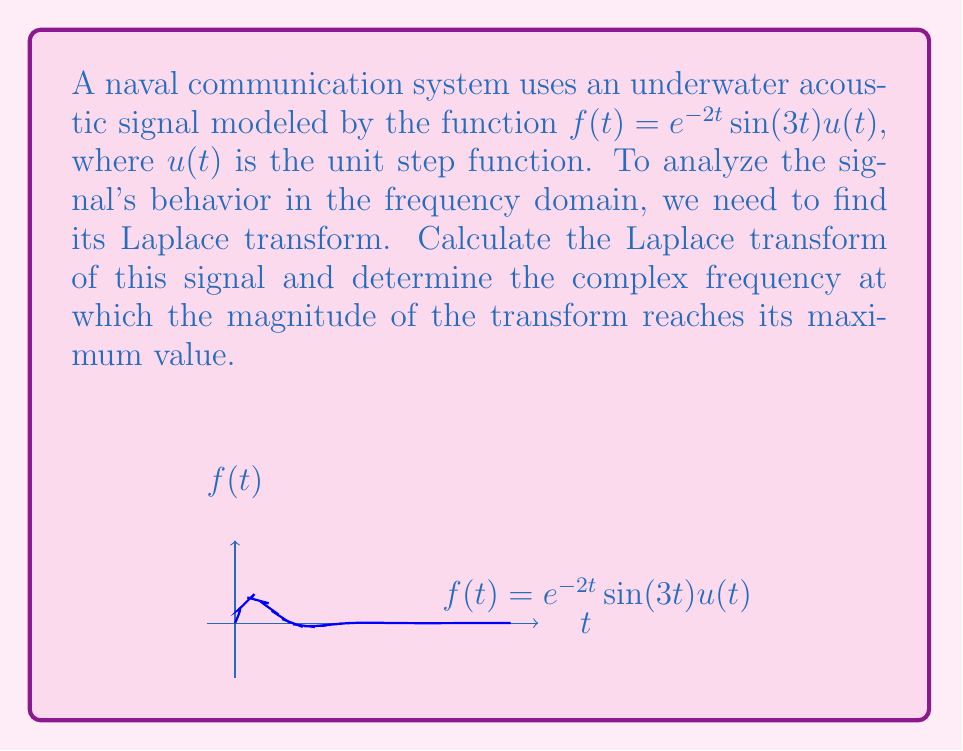What is the answer to this math problem? Let's approach this step-by-step:

1) The Laplace transform of $f(t) = e^{-2t}\sin(3t)u(t)$ is given by:

   $$F(s) = \mathcal{L}\{f(t)\} = \int_0^\infty e^{-2t}\sin(3t)e^{-st}dt$$

2) We can use the Laplace transform formula for $e^{at}\sin(bt)$:

   $$\mathcal{L}\{e^{at}\sin(bt)\} = \frac{b}{(s-a)^2 + b^2}$$

3) In our case, $a = -2$ and $b = 3$. Substituting these values:

   $$F(s) = \frac{3}{(s+2)^2 + 3^2} = \frac{3}{(s+2)^2 + 9}$$

4) To find the magnitude of $F(s)$, we need:

   $$|F(s)| = \frac{3}{\sqrt{((s+2)^2 + 9)^2}}$$

5) The maximum magnitude occurs when the denominator is at its minimum. The denominator is minimized when $s = -2$ (which makes the $(s+2)^2$ term zero).

6) At $s = -2$, we have:

   $$|F(-2)| = \frac{3}{\sqrt{9^2}} = \frac{3}{9} = \frac{1}{3}$$

7) Therefore, the complex frequency at which the magnitude reaches its maximum is $s = -2$.
Answer: $s = -2$ 